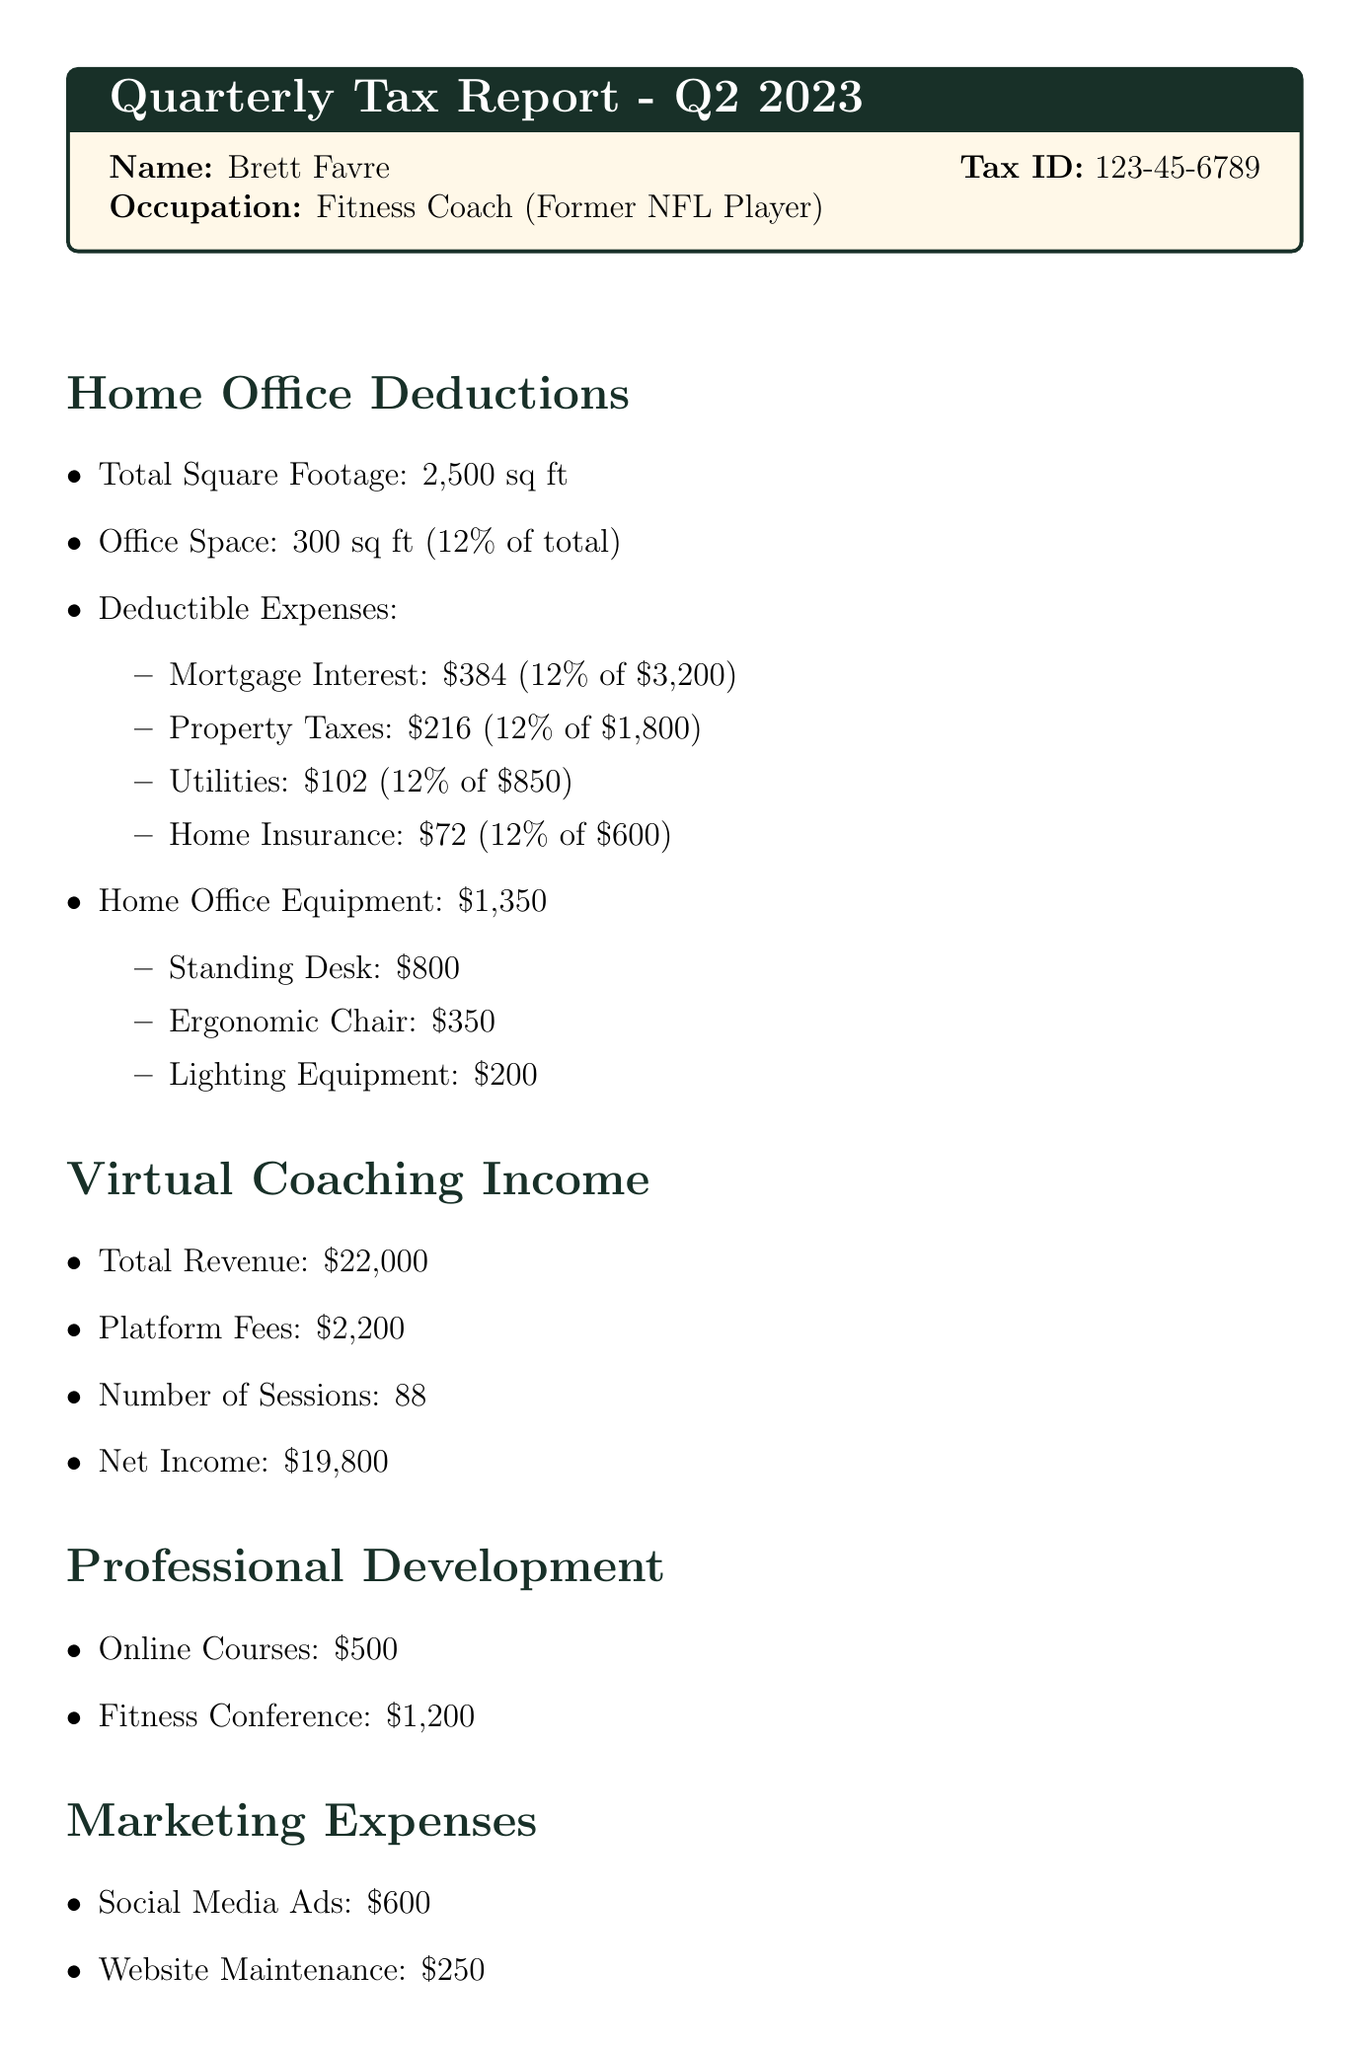What is the name of the individual? The name of the individual is presented in the personal info section of the report.
Answer: Brett Favre What is the total square footage of the home? The total square footage is mentioned under home office deductions in the document.
Answer: 2500 sq ft What percentage of the home is used for business? The percentage used for business is specified in the deductions section of the report.
Answer: 12% How much was spent on home office equipment? The amount spent on home office equipment is detailed in the home office deductions section.
Answer: 1350 dollars What is the total revenue generated from virtual coaching? Total revenue from virtual coaching is stated in the virtual coaching income section of the report.
Answer: 22000 dollars How many coaching sessions were conducted? The number of coaching sessions can be found in the virtual coaching income section of the document.
Answer: 88 What was the total amount of professional development expenses? The total professional development expenses are the sum mentioned in that specific section of the document.
Answer: 1700 dollars What are the total marketing expenses? The total marketing expenses can be calculated by adding the expenses in the marketing expenses section.
Answer: 850 dollars What is the taxable income reported? The taxable income is provided in the summary section of the financial report.
Answer: 15416 dollars 